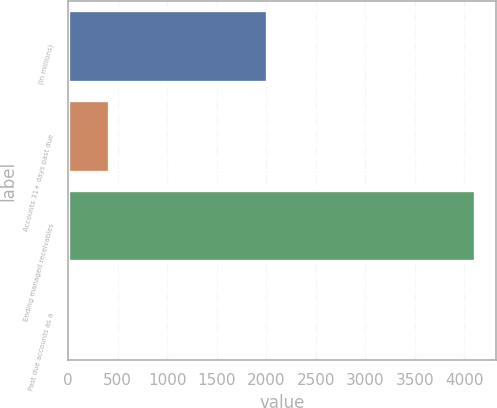Convert chart. <chart><loc_0><loc_0><loc_500><loc_500><bar_chart><fcel>(In millions)<fcel>Accounts 31+ days past due<fcel>Ending managed receivables<fcel>Past due accounts as a<nl><fcel>2010<fcel>414.19<fcel>4112.7<fcel>3.24<nl></chart> 